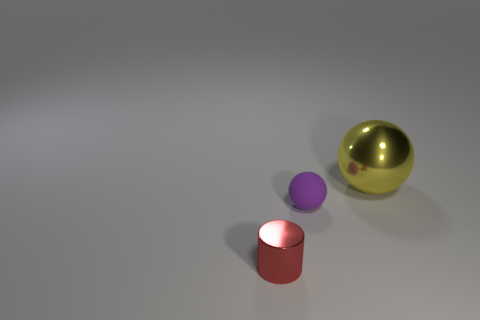Add 1 large yellow metallic things. How many objects exist? 4 Subtract all cylinders. How many objects are left? 2 Subtract all green matte cubes. Subtract all rubber balls. How many objects are left? 2 Add 1 purple balls. How many purple balls are left? 2 Add 3 small purple things. How many small purple things exist? 4 Subtract 0 green cubes. How many objects are left? 3 